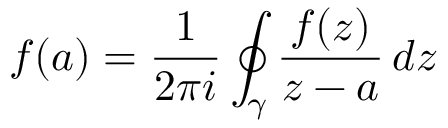<formula> <loc_0><loc_0><loc_500><loc_500>f ( a ) = { \frac { 1 } { 2 \pi i } } \oint _ { \gamma } { \frac { f ( z ) } { z - a } } \, d z</formula> 